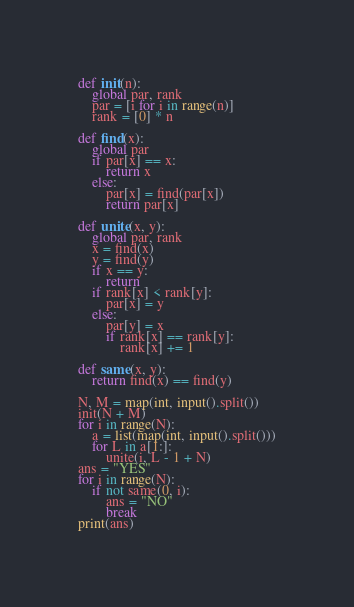<code> <loc_0><loc_0><loc_500><loc_500><_Python_>def init(n):
    global par, rank
    par = [i for i in range(n)]
    rank = [0] * n

def find(x):
    global par
    if par[x] == x:
        return x
    else:
        par[x] = find(par[x])
        return par[x]

def unite(x, y):
    global par, rank
    x = find(x)
    y = find(y)
    if x == y:
        return
    if rank[x] < rank[y]:
        par[x] = y
    else:
        par[y] = x
        if rank[x] == rank[y]:
            rank[x] += 1

def same(x, y):
    return find(x) == find(y)

N, M = map(int, input().split())
init(N + M)
for i in range(N):
    a = list(map(int, input().split()))
    for L in a[1:]:
        unite(i, L - 1 + N)
ans = "YES"
for i in range(N):
    if not same(0, i):
        ans = "NO"
        break
print(ans)</code> 